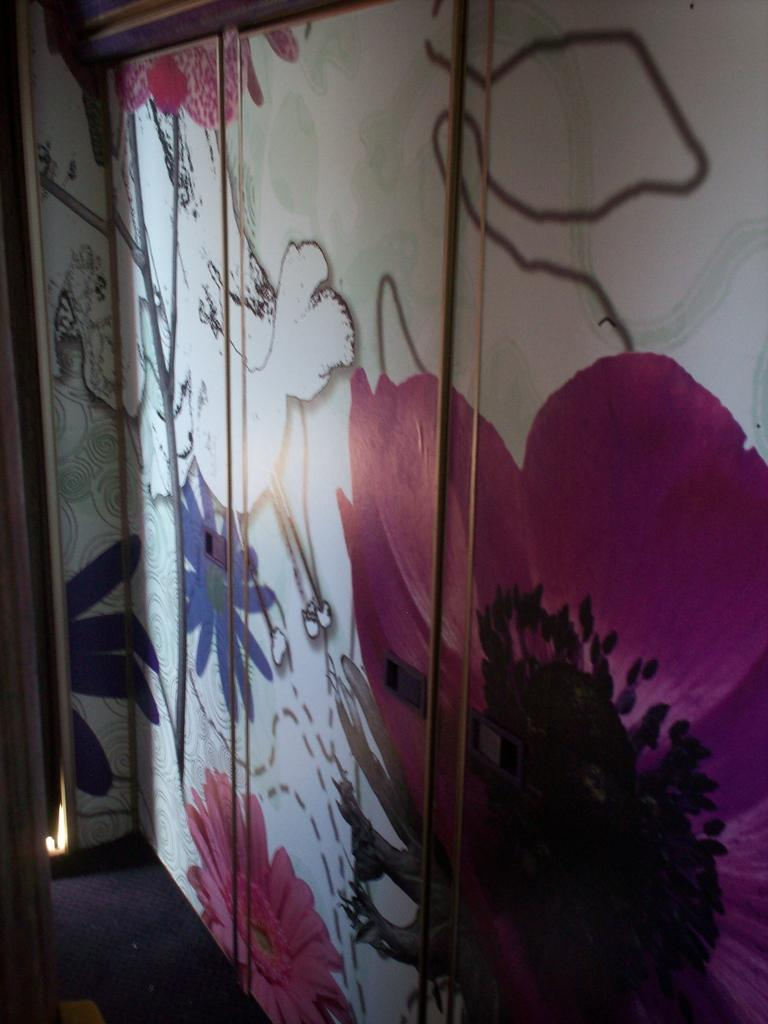What type of furniture is present in the image? There is a cupboard in the image. What feature of the cupboard is mentioned in the facts? The cupboard doors have a design on them. How many ants can be seen crawling on the cupboard in the image? There are no ants present in the image. What color is the root of the cupboard in the image? The facts do not mention the color of the cupboard or any roots associated with it. 